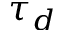<formula> <loc_0><loc_0><loc_500><loc_500>\tau _ { d }</formula> 